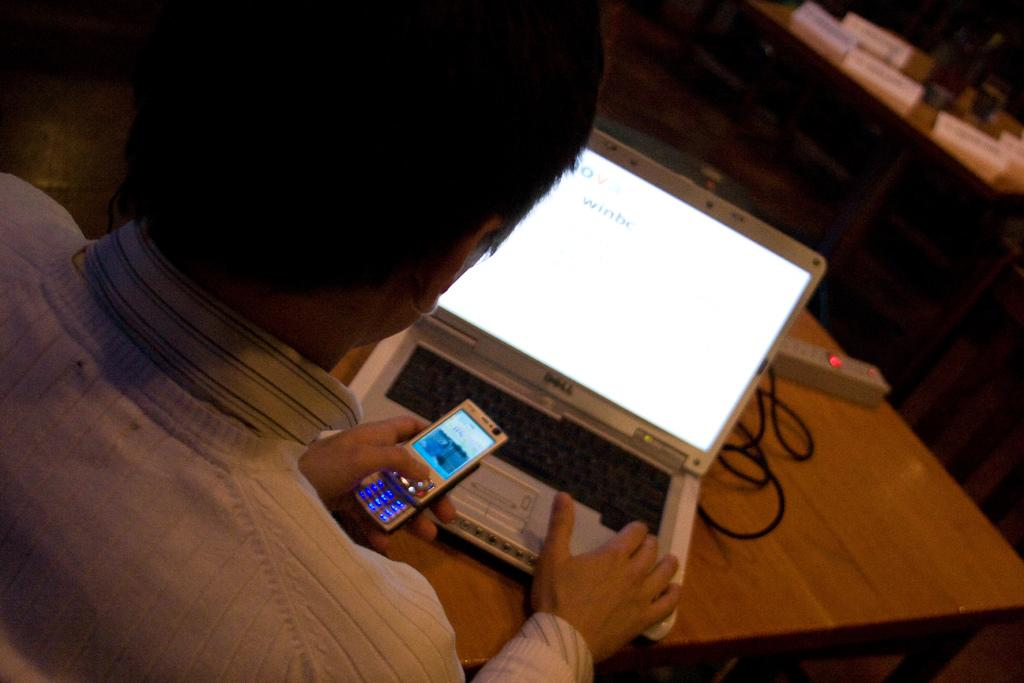<image>
Relay a brief, clear account of the picture shown. Her laptop computer is a Dell brand and her screen says winbe. 